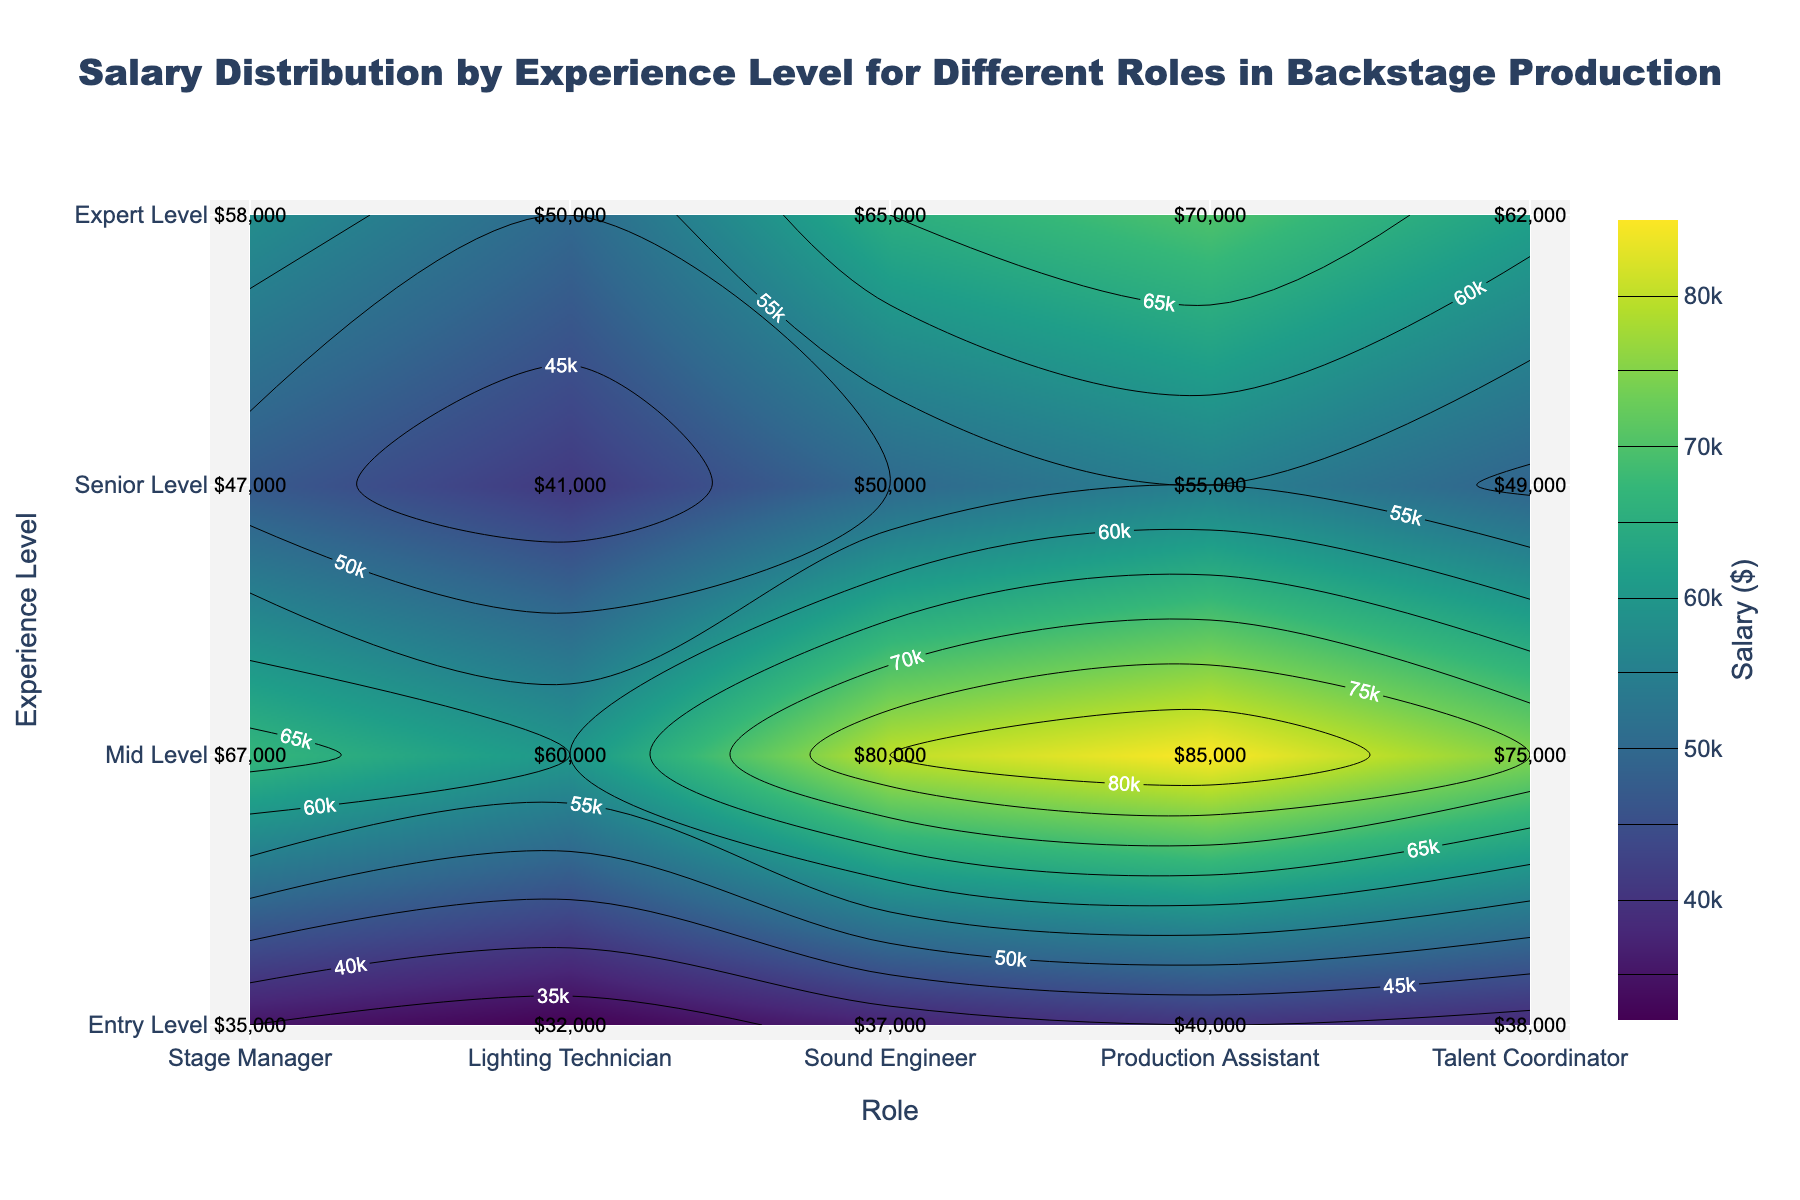What is the title of the plot? The title is usually displayed at the top of the plot. Here, it is clearly stated as the main heading above the visual graph.
Answer: Salary Distribution by Experience Level for Different Roles in Backstage Production What is the salary for a Senior Level Sound Engineer? Locate "Senior Level" on the y-axis and "Sound Engineer" on the x-axis, then find the corresponding value at the intersection of these two points.
Answer: 65000 Which role has the highest salary at the Expert Level? First, focus on the "Expert Level" experience. Then, compare the salary values across all roles at this level.
Answer: Stage Manager How does the salary of a Mid Level Lighting Technician compare to a Mid Level Production Assistant? Find the salary for both roles at the "Mid Level" experience. The Lighting Technician earns 47000, and the Production Assistant earns 41000. Compare these values.
Answer: Lighting Technician earns 6000 more Which role shows the highest salary increase from Entry Level to Senior Level? For each role, calculate the difference between the Senior Level and Entry Level salaries. Compare all differences to find the highest one.
Answer: Stage Manager What is the average salary for an Entry Level role across all roles? Sum the salaries for all Entry Level roles: 40000 + 35000 + 37000 + 32000 + 38000 = 182000. Then divide by the number of roles, which is 5.
Answer: 36400 How does the salary distribution change with experience level? Identify the contours and labels indicating salary across experience levels. Generally, salaries increase as experience level increases, which can be seen from upper right to lower left salary increases.
Answer: Salaries rise with experience What is the salary difference between an Expert Level and Mid Level Talent Coordinator? Find the salaries of the Talent Coordinator at both Expert Level (75000) and Mid Level (49000), then calculate the difference.
Answer: 26000 Which experience level has the steepest salary gradient for the role of Stage Manager? Analyze the salary difference between consecutive experience levels for Stage Manager (Entry: 40000, Mid: 55000, Senior: 70000, Expert: 85000). The steepest gradient is the largest difference.
Answer: Entry Level to Mid Level What is the lowest salary value on the plot, and which role does it correspond to? Identify the lowest number within the contour values indicated on the plot. It corresponds to the Entry Level Production Assistant role, which is 32000.
Answer: 32000, Production Assistant 